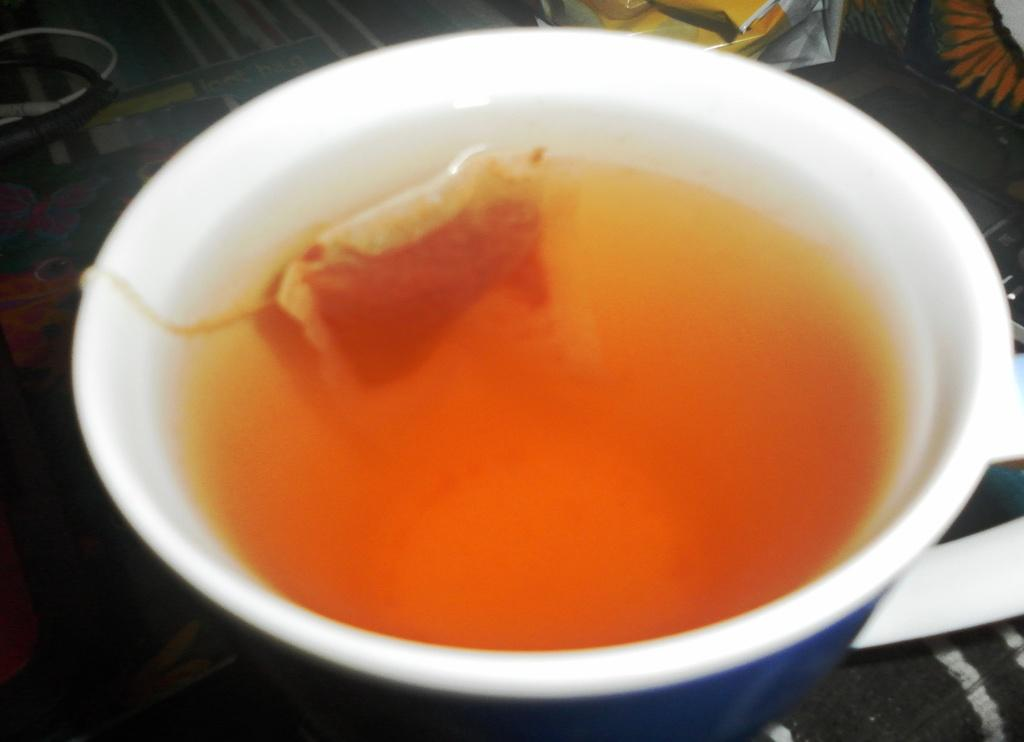What piece of furniture is present in the image? There is a table in the image. What is covering the table? The table has a tablecloth. What beverage can be seen on the table? There is a cup of tea on the table. How does the mailbox feel about the cup of tea on the table? There is no mailbox present in the image, so it cannot have any feelings about the cup of tea. 